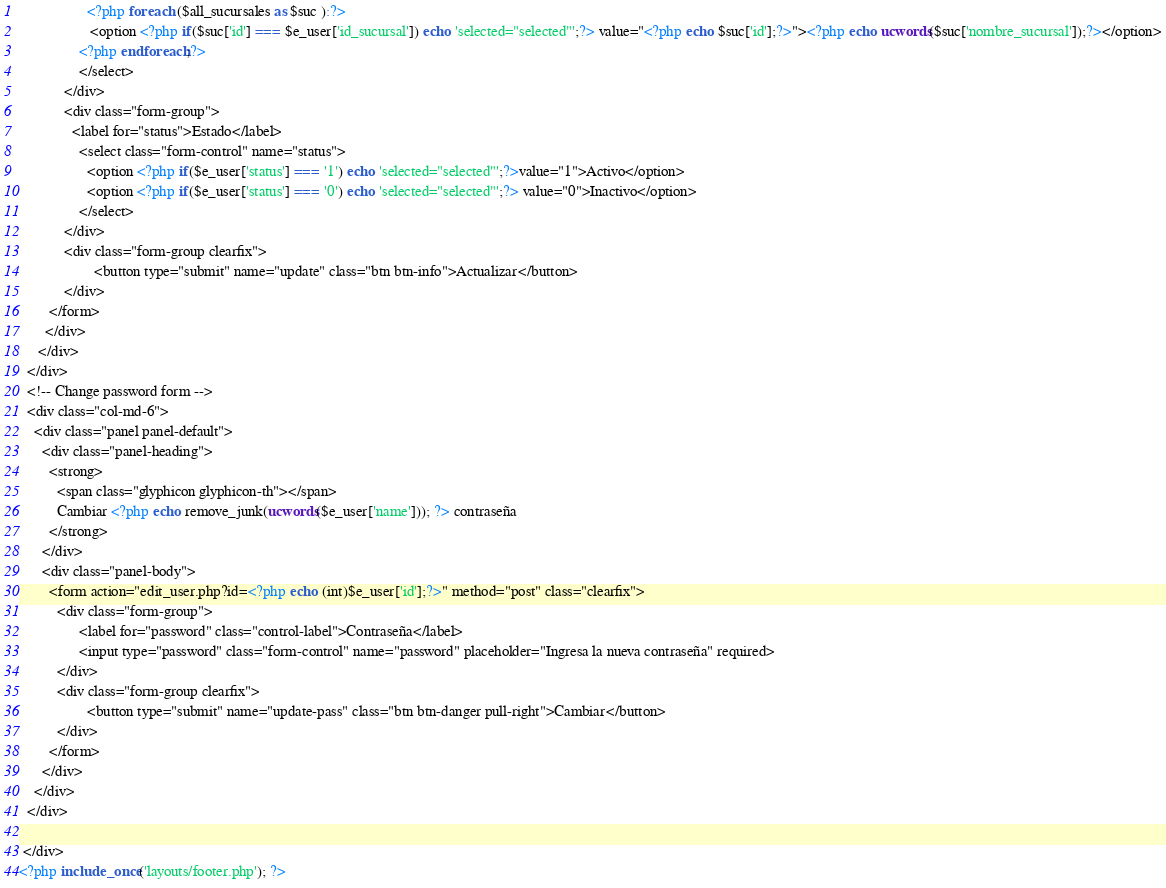Convert code to text. <code><loc_0><loc_0><loc_500><loc_500><_PHP_>                  <?php foreach ($all_sucursales as $suc ):?>
                   <option <?php if($suc['id'] === $e_user['id_sucursal']) echo 'selected="selected"';?> value="<?php echo $suc['id'];?>"><?php echo ucwords($suc['nombre_sucursal']);?></option>
                <?php endforeach;?>
                </select>
            </div>
            <div class="form-group">
              <label for="status">Estado</label>
                <select class="form-control" name="status">
                  <option <?php if($e_user['status'] === '1') echo 'selected="selected"';?>value="1">Activo</option>
                  <option <?php if($e_user['status'] === '0') echo 'selected="selected"';?> value="0">Inactivo</option>
                </select>
            </div>
            <div class="form-group clearfix">
                    <button type="submit" name="update" class="btn btn-info">Actualizar</button>
            </div>
        </form>
       </div>
     </div>
  </div>
  <!-- Change password form -->
  <div class="col-md-6">
    <div class="panel panel-default">
      <div class="panel-heading">
        <strong>
          <span class="glyphicon glyphicon-th"></span>
          Cambiar <?php echo remove_junk(ucwords($e_user['name'])); ?> contraseña
        </strong>
      </div>
      <div class="panel-body">
        <form action="edit_user.php?id=<?php echo (int)$e_user['id'];?>" method="post" class="clearfix">
          <div class="form-group">
                <label for="password" class="control-label">Contraseña</label>
                <input type="password" class="form-control" name="password" placeholder="Ingresa la nueva contraseña" required>
          </div>
          <div class="form-group clearfix">
                  <button type="submit" name="update-pass" class="btn btn-danger pull-right">Cambiar</button>
          </div>
        </form>
      </div>
    </div>
  </div>

 </div>
<?php include_once('layouts/footer.php'); ?>
</code> 